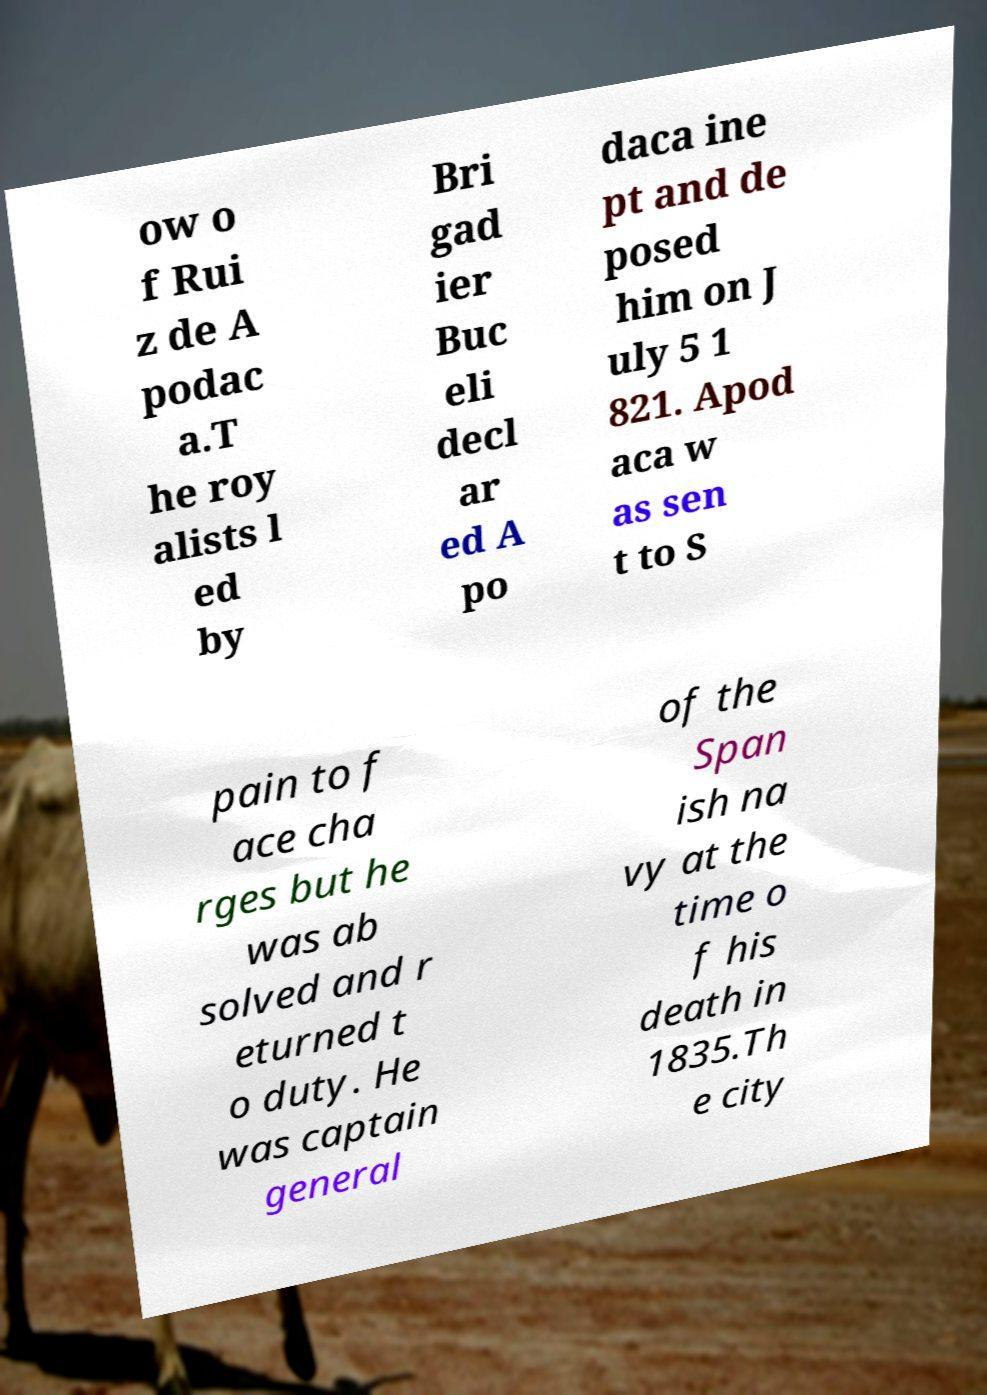Please read and relay the text visible in this image. What does it say? ow o f Rui z de A podac a.T he roy alists l ed by Bri gad ier Buc eli decl ar ed A po daca ine pt and de posed him on J uly 5 1 821. Apod aca w as sen t to S pain to f ace cha rges but he was ab solved and r eturned t o duty. He was captain general of the Span ish na vy at the time o f his death in 1835.Th e city 